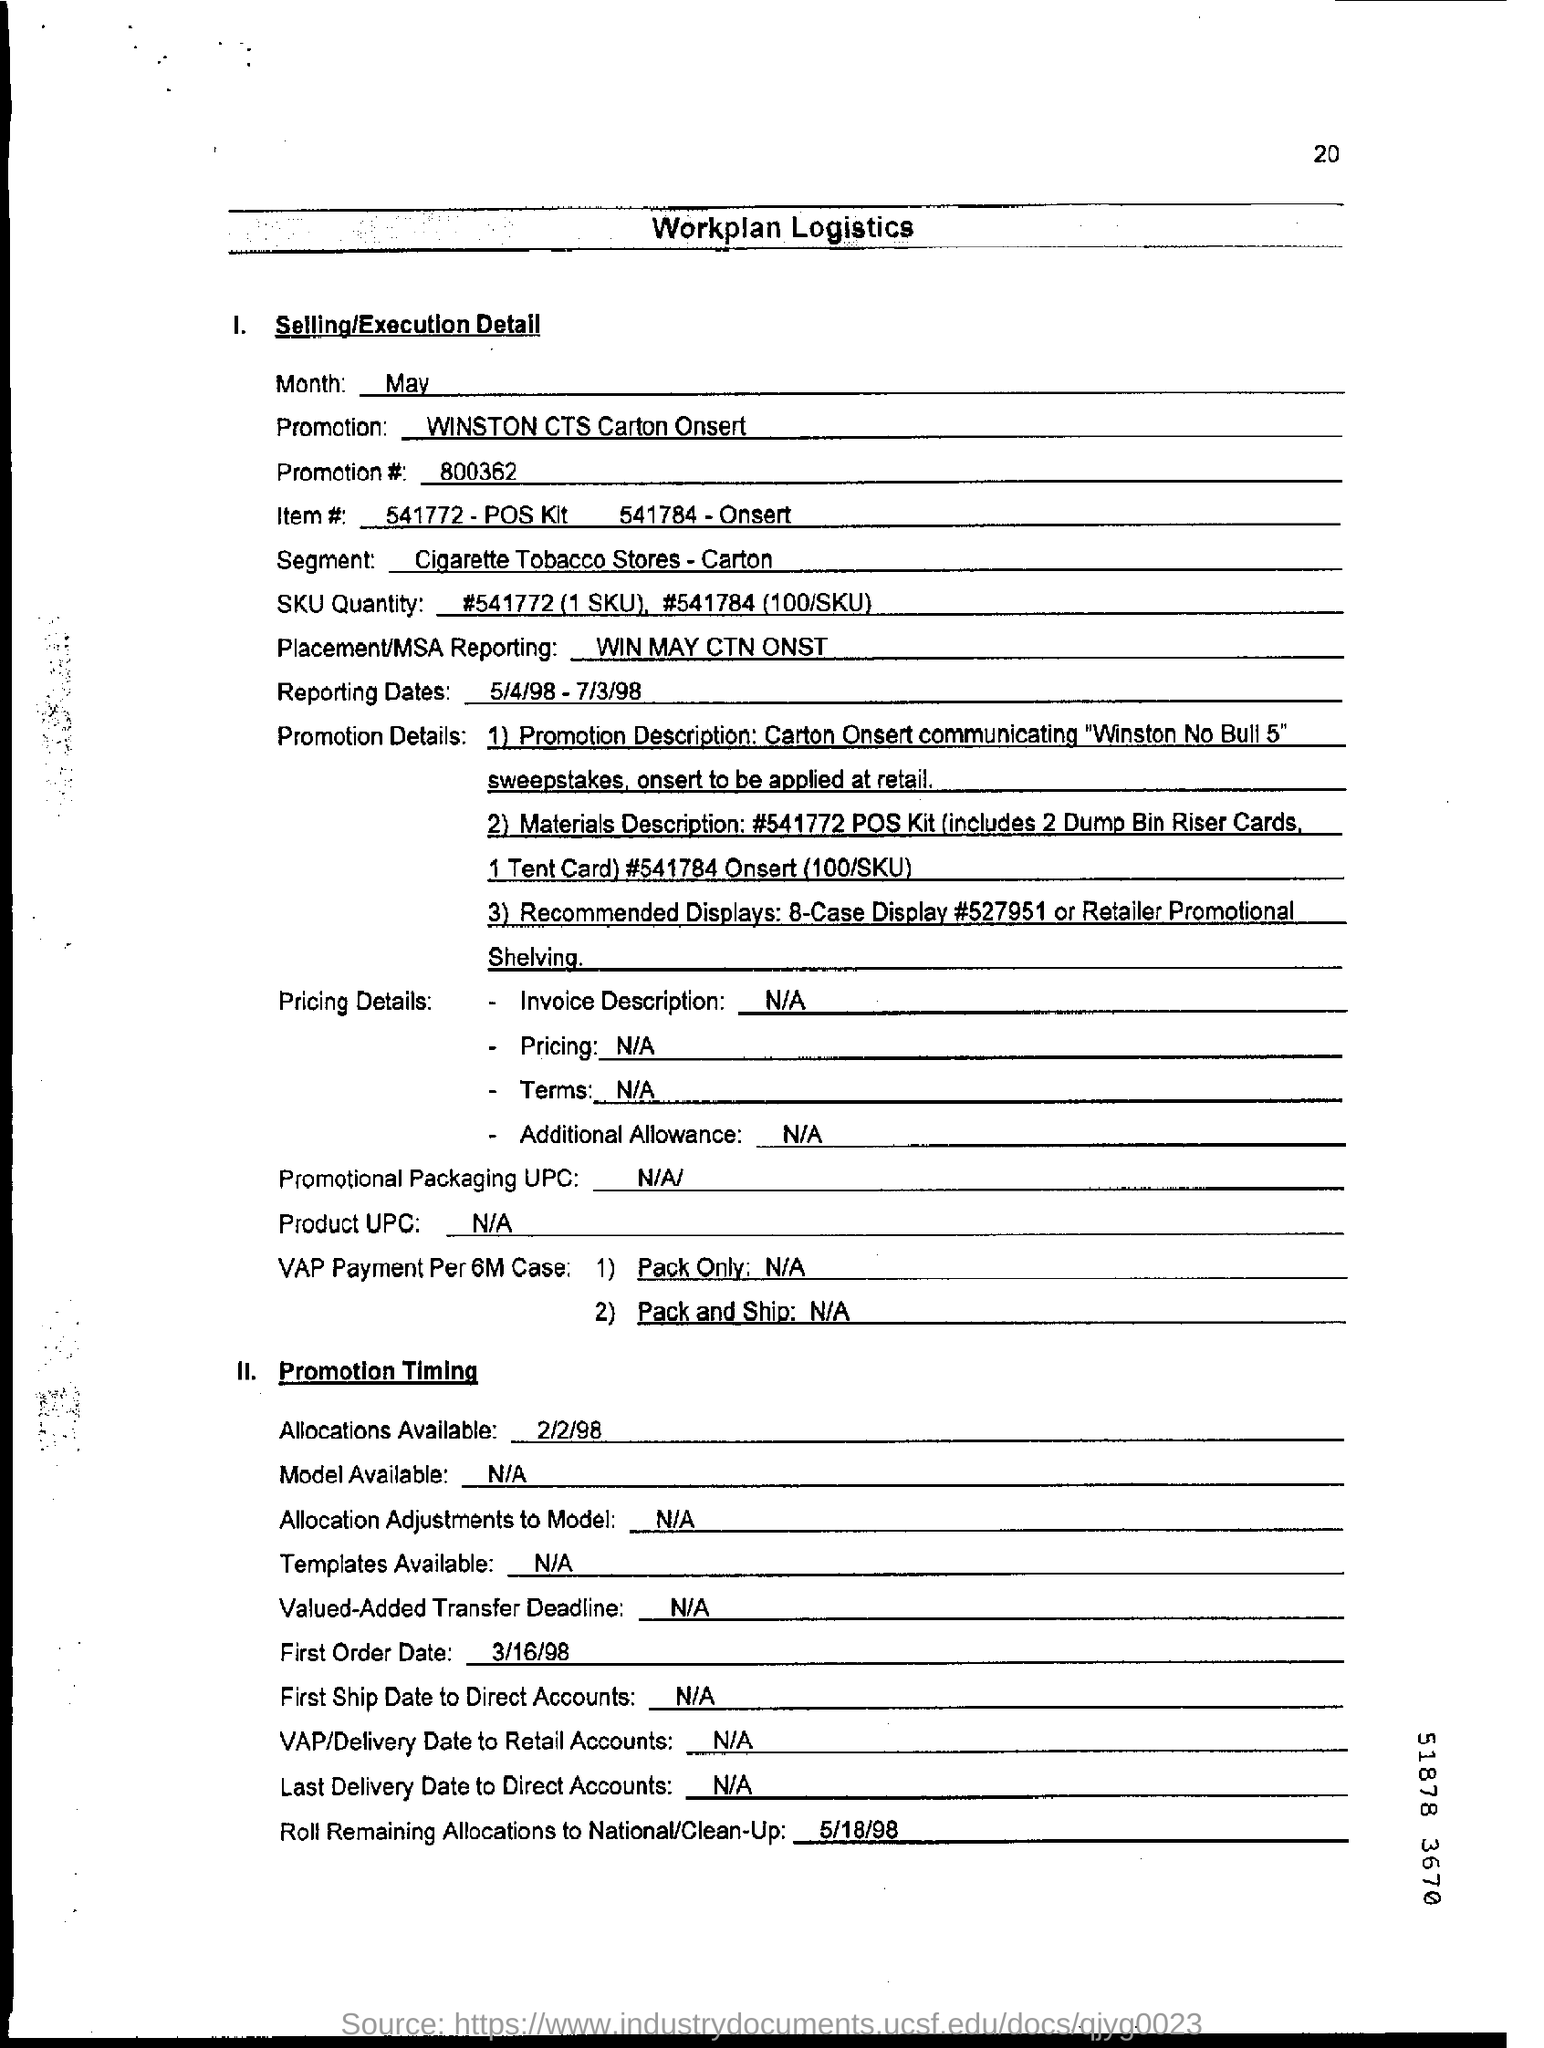What is the Promotion #  mentioned in the document?
Your answer should be very brief. 800362. What is the reporting dates as per the dcoument?
Make the answer very short. 5/4/98 - 7/3/98. What is the Placement/MSA Reporting as per the dcoument?
Offer a terse response. WIN MAY CTN ONST. 